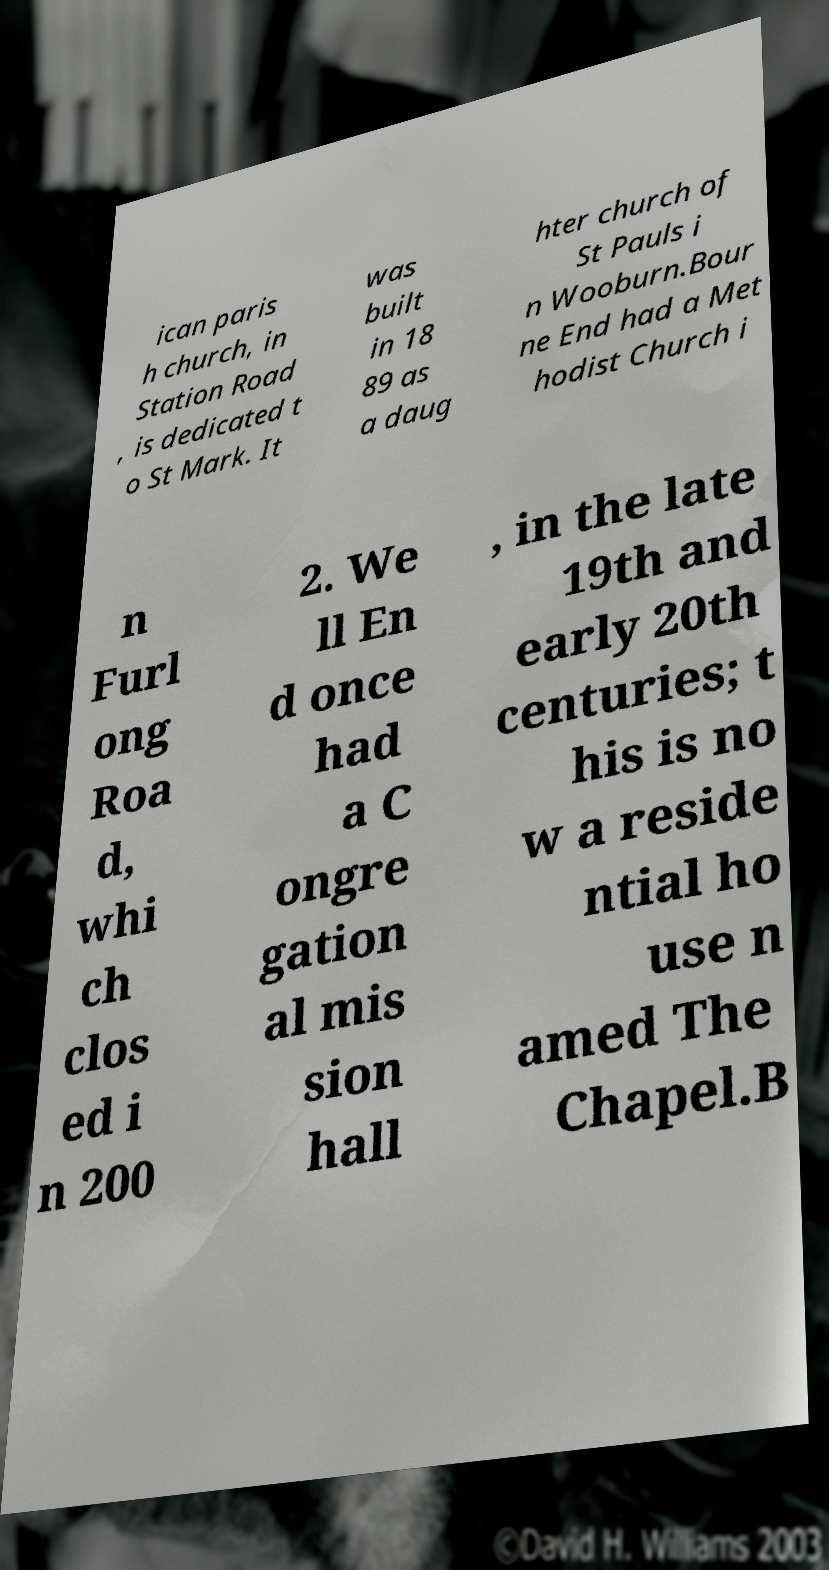What messages or text are displayed in this image? I need them in a readable, typed format. ican paris h church, in Station Road , is dedicated t o St Mark. It was built in 18 89 as a daug hter church of St Pauls i n Wooburn.Bour ne End had a Met hodist Church i n Furl ong Roa d, whi ch clos ed i n 200 2. We ll En d once had a C ongre gation al mis sion hall , in the late 19th and early 20th centuries; t his is no w a reside ntial ho use n amed The Chapel.B 